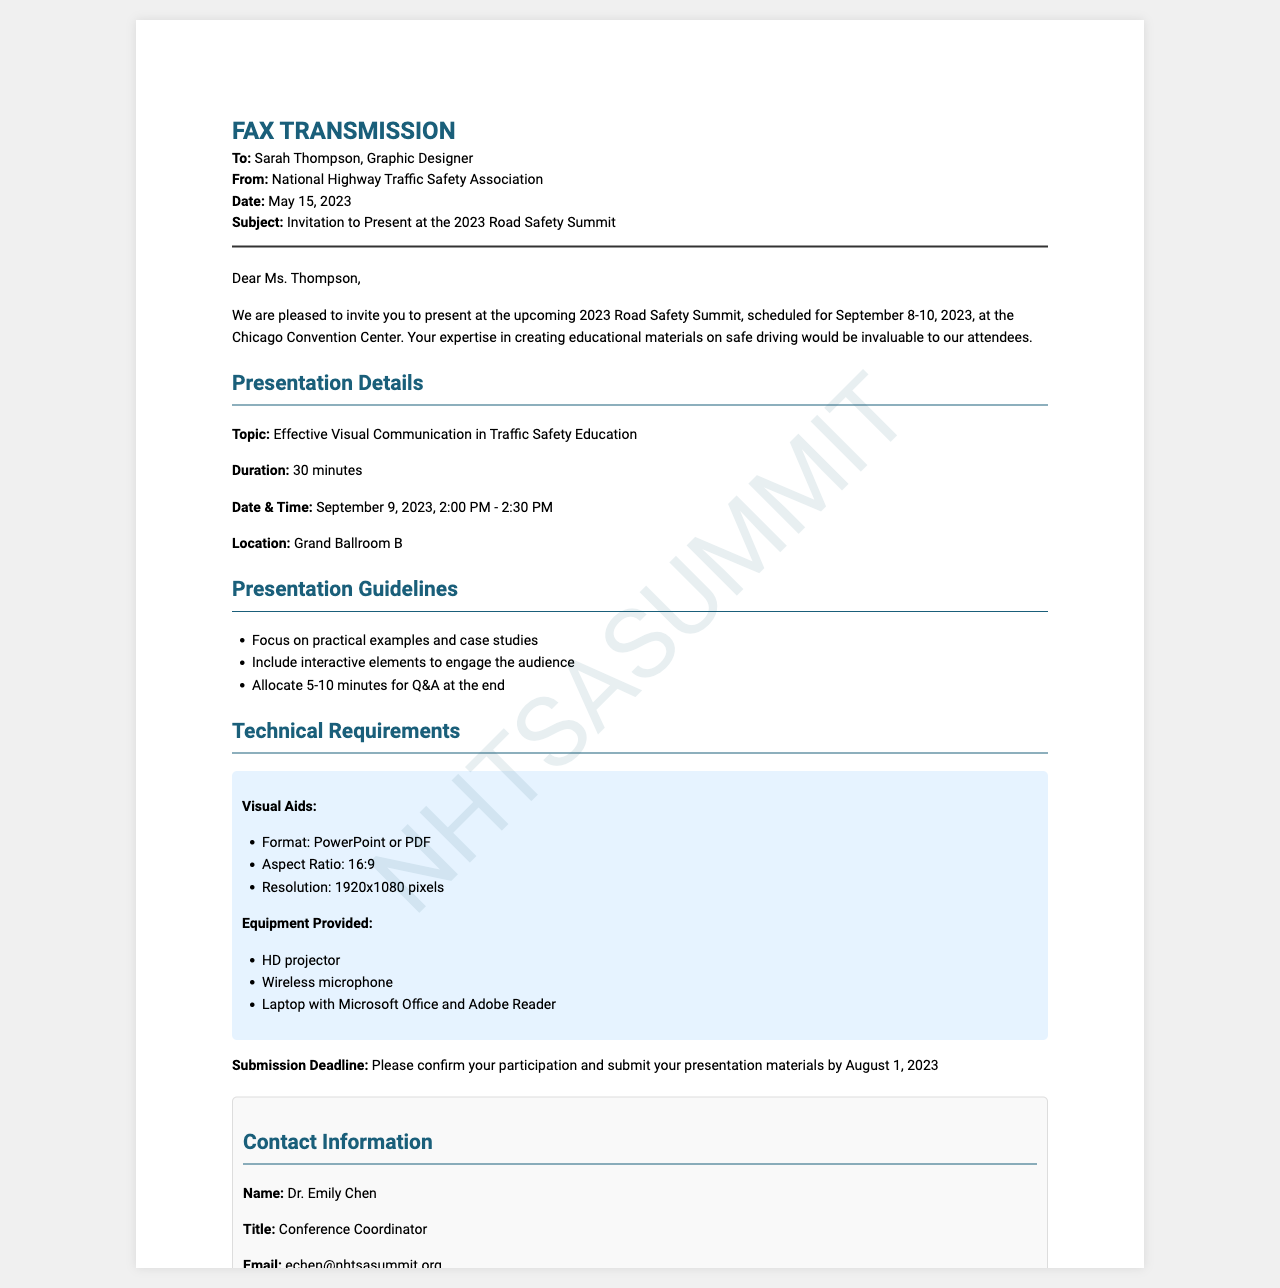what is the date of the conference? The document specifies that the 2023 Road Safety Summit is scheduled for September 8-10, 2023.
Answer: September 8-10, 2023 who is the sender of the fax? The fax states that it is from the National Highway Traffic Safety Association.
Answer: National Highway Traffic Safety Association what is the duration of the presentation? The document mentions that the presentation duration is 30 minutes.
Answer: 30 minutes what is the submission deadline for presentation materials? The fax indicates that the submission deadline is August 1, 2023.
Answer: August 1, 2023 what equipment will be provided for the presentation? The document lists the equipment provided including an HD projector, wireless microphone, and a laptop.
Answer: HD projector, wireless microphone, laptop what topic will be covered in the presentation? The fax details that the topic is "Effective Visual Communication in Traffic Safety Education."
Answer: Effective Visual Communication in Traffic Safety Education how many minutes should be allocated for Q&A at the end? The guidelines suggest allocating 5-10 minutes for Q&A.
Answer: 5-10 minutes who should be contacted for more information? The document provides the contact information for Dr. Emily Chen as the conference coordinator.
Answer: Dr. Emily Chen what aspect ratio should the visual aids be? The technical requirements specify that the aspect ratio should be 16:9.
Answer: 16:9 